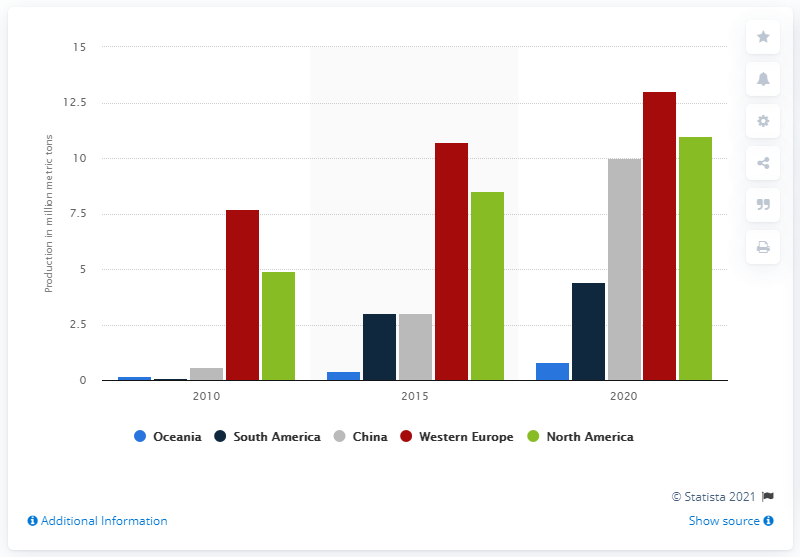Outline some significant characteristics in this image. The production of wood pellets in South America is projected to be 4.4 million tons in 2015. 